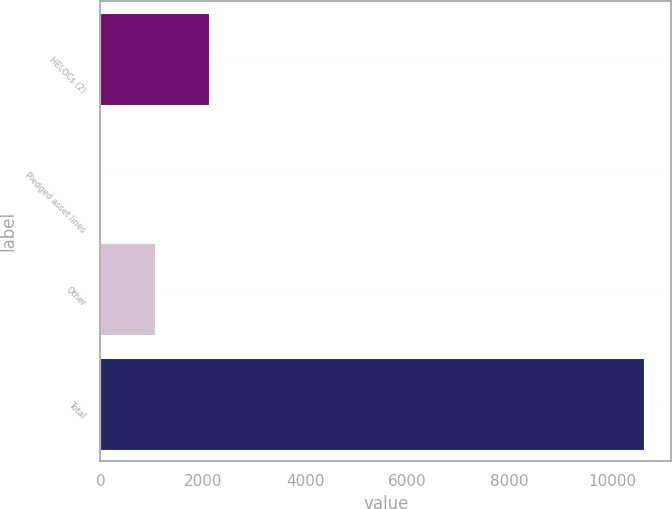<chart> <loc_0><loc_0><loc_500><loc_500><bar_chart><fcel>HELOCs (2)<fcel>Pledged asset lines<fcel>Other<fcel>Total<nl><fcel>2127.6<fcel>4<fcel>1065.8<fcel>10622<nl></chart> 